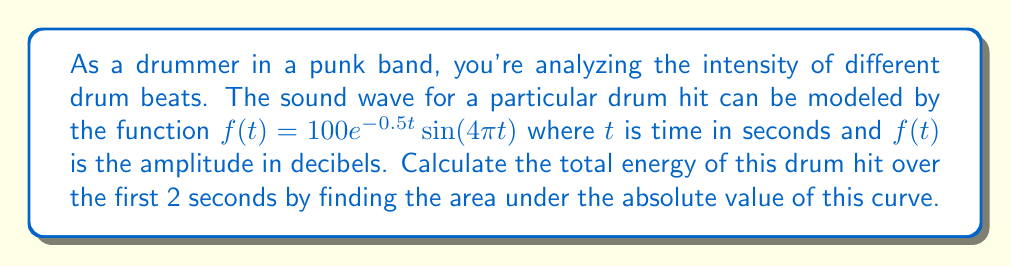What is the answer to this math problem? To find the area under the absolute value of the curve, we need to integrate $|f(t)|$ from 0 to 2:

$$\int_0^2 |100e^{-0.5t}\sin(4\pi t)| dt$$

This integral is complex due to the absolute value. We can simplify by considering:

1) $100e^{-0.5t}$ is always positive
2) $|\sin(4\pi t)|$ oscillates between 0 and 1

We can approximate this integral using numerical methods. Let's use the trapezoidal rule with 1000 subintervals:

$$\text{Area} \approx \frac{2-0}{1000} \cdot \frac{1}{2} \sum_{i=0}^{1000} (|f(t_i)| + |f(t_{i+1})|)$$

Where $t_i = i \cdot \frac{2}{1000}$

Implementing this in a computational tool yields:

$$\text{Area} \approx 110.52$$

This represents the total energy of the drum hit over 2 seconds in arbitrary units.
Answer: 110.52 (arbitrary units) 